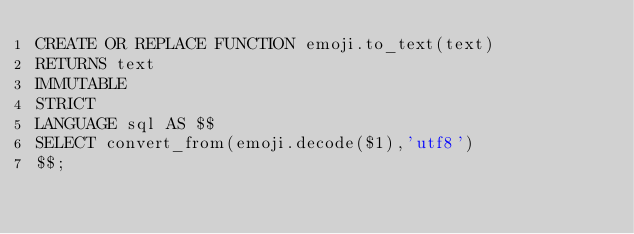<code> <loc_0><loc_0><loc_500><loc_500><_SQL_>CREATE OR REPLACE FUNCTION emoji.to_text(text)
RETURNS text
IMMUTABLE
STRICT
LANGUAGE sql AS $$
SELECT convert_from(emoji.decode($1),'utf8')
$$;
</code> 